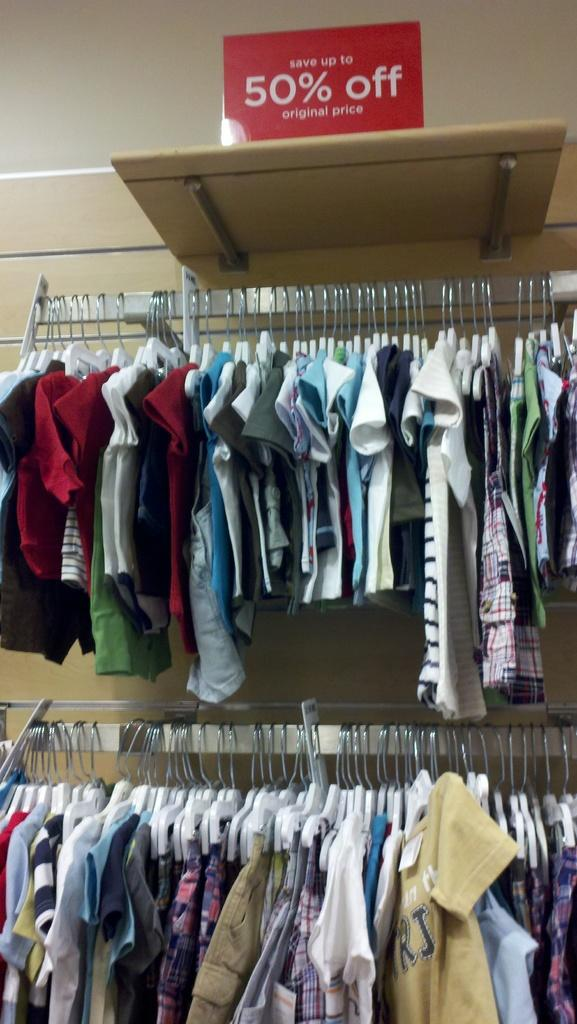<image>
Relay a brief, clear account of the picture shown. Stand for a clothing store with a sign that says  50% off. 